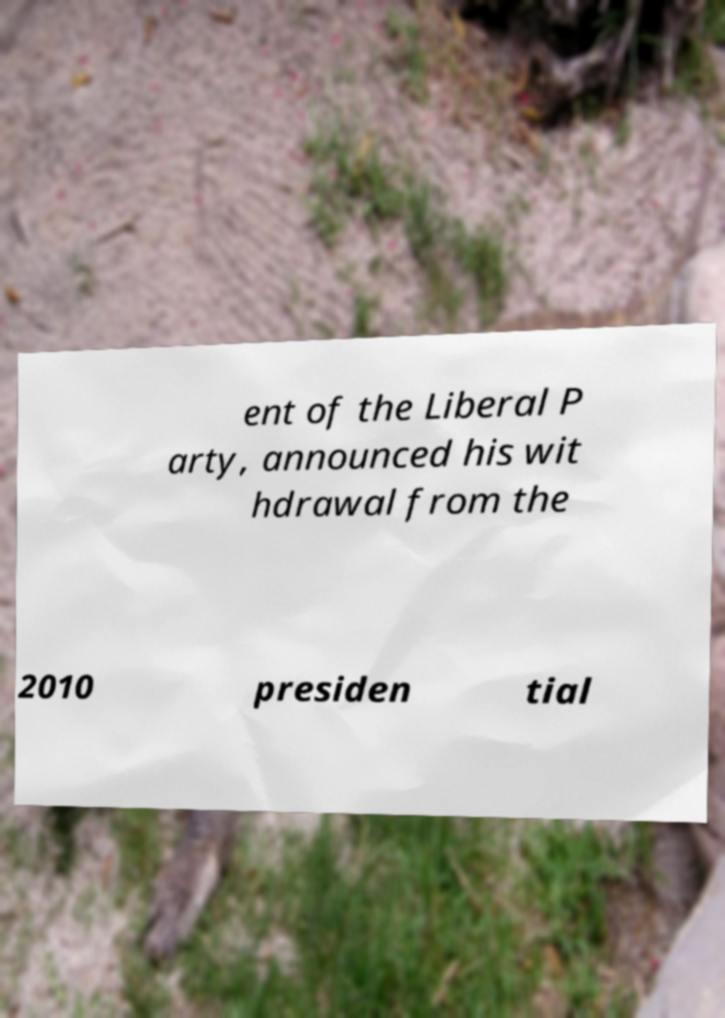There's text embedded in this image that I need extracted. Can you transcribe it verbatim? ent of the Liberal P arty, announced his wit hdrawal from the 2010 presiden tial 